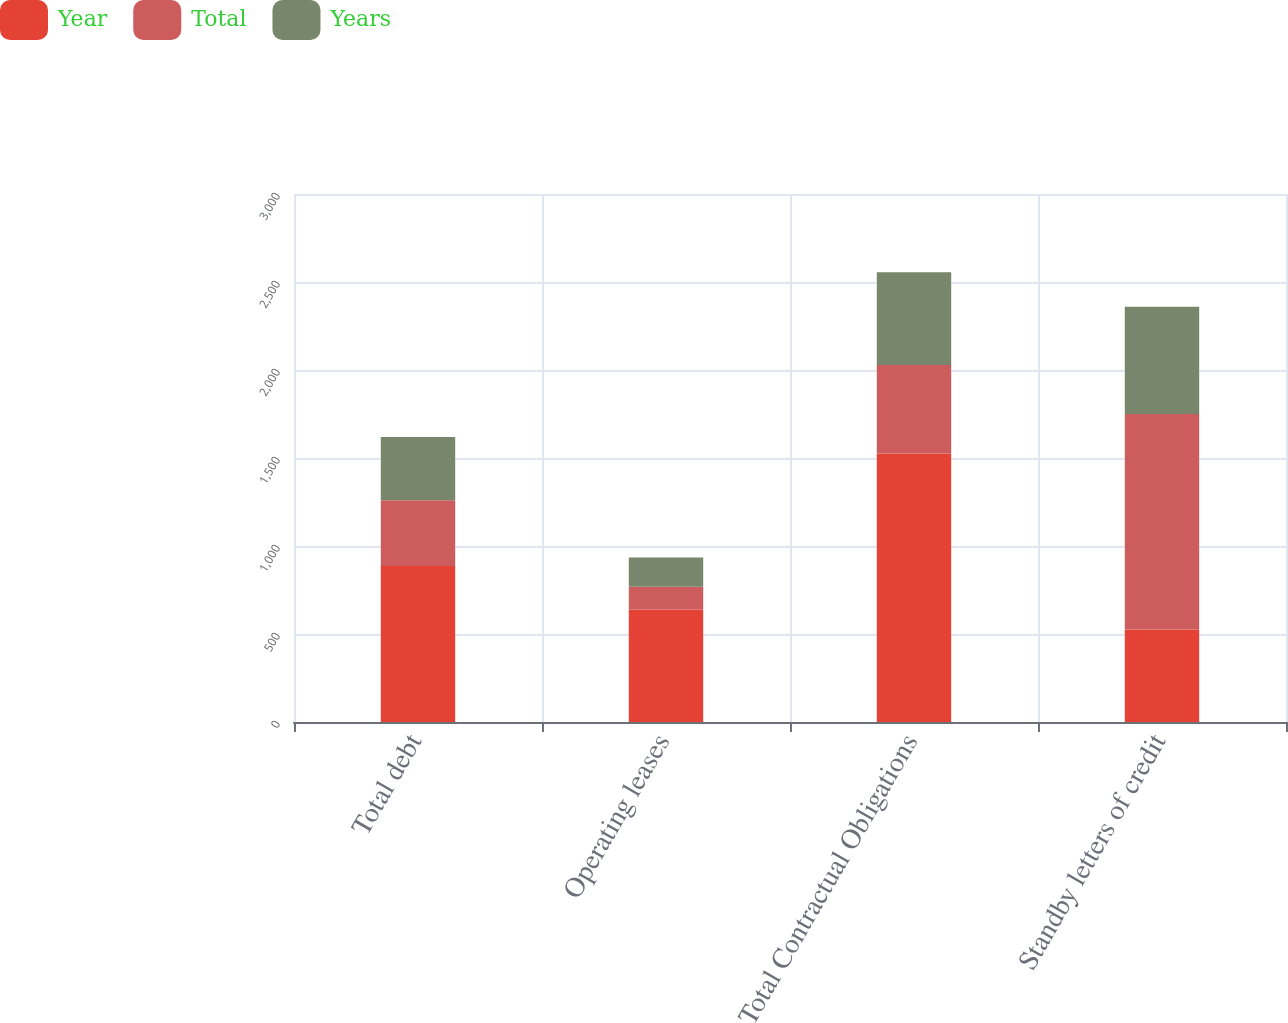Convert chart to OTSL. <chart><loc_0><loc_0><loc_500><loc_500><stacked_bar_chart><ecel><fcel>Total debt<fcel>Operating leases<fcel>Total Contractual Obligations<fcel>Standby letters of credit<nl><fcel>Year<fcel>887<fcel>639<fcel>1526<fcel>526<nl><fcel>Total<fcel>373<fcel>130<fcel>503<fcel>1224<nl><fcel>Years<fcel>360<fcel>166<fcel>526<fcel>609<nl></chart> 